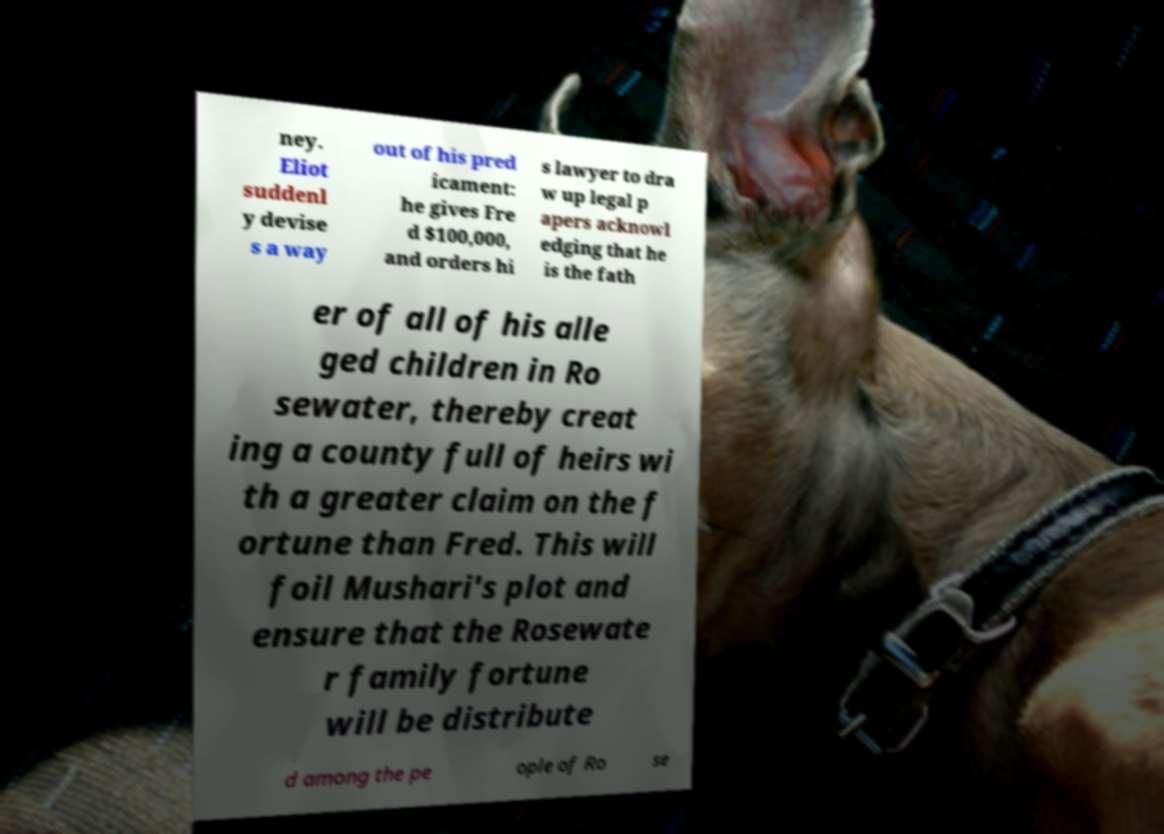For documentation purposes, I need the text within this image transcribed. Could you provide that? ney. Eliot suddenl y devise s a way out of his pred icament: he gives Fre d $100,000, and orders hi s lawyer to dra w up legal p apers acknowl edging that he is the fath er of all of his alle ged children in Ro sewater, thereby creat ing a county full of heirs wi th a greater claim on the f ortune than Fred. This will foil Mushari's plot and ensure that the Rosewate r family fortune will be distribute d among the pe ople of Ro se 